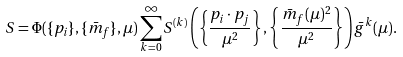<formula> <loc_0><loc_0><loc_500><loc_500>S = \Phi ( \{ p _ { i } \} , \{ \bar { m } _ { f } \} , \mu ) \sum _ { k = 0 } ^ { \infty } S ^ { ( k ) } \left ( \left \{ \frac { p _ { i } \cdot p _ { j } } { \mu ^ { 2 } } \right \} , \left \{ \frac { \bar { m } _ { f } ( \mu ) ^ { 2 } } { \mu ^ { 2 } } \right \} \right ) \bar { g } ^ { k } ( \mu ) .</formula> 